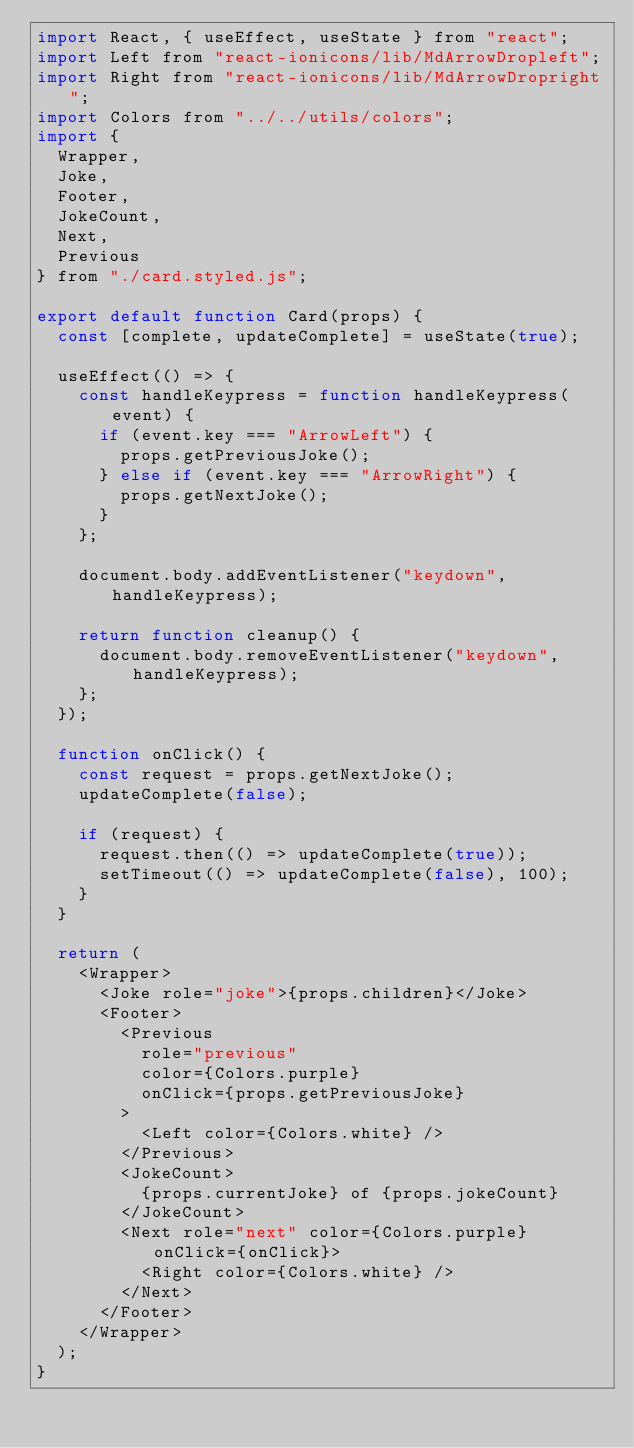Convert code to text. <code><loc_0><loc_0><loc_500><loc_500><_JavaScript_>import React, { useEffect, useState } from "react";
import Left from "react-ionicons/lib/MdArrowDropleft";
import Right from "react-ionicons/lib/MdArrowDropright";
import Colors from "../../utils/colors";
import {
  Wrapper,
  Joke,
  Footer,
  JokeCount,
  Next,
  Previous
} from "./card.styled.js";

export default function Card(props) {
  const [complete, updateComplete] = useState(true);

  useEffect(() => {
    const handleKeypress = function handleKeypress(event) {
      if (event.key === "ArrowLeft") {
        props.getPreviousJoke();
      } else if (event.key === "ArrowRight") {
        props.getNextJoke();
      }
    };

    document.body.addEventListener("keydown", handleKeypress);

    return function cleanup() {
      document.body.removeEventListener("keydown", handleKeypress);
    };
  });

  function onClick() {
    const request = props.getNextJoke();
    updateComplete(false);

    if (request) {
      request.then(() => updateComplete(true));
      setTimeout(() => updateComplete(false), 100);
    }
  }

  return (
    <Wrapper>
      <Joke role="joke">{props.children}</Joke>
      <Footer>
        <Previous
          role="previous"
          color={Colors.purple}
          onClick={props.getPreviousJoke}
        >
          <Left color={Colors.white} />
        </Previous>
        <JokeCount>
          {props.currentJoke} of {props.jokeCount}
        </JokeCount>
        <Next role="next" color={Colors.purple} onClick={onClick}>
          <Right color={Colors.white} />
        </Next>
      </Footer>
    </Wrapper>
  );
}
</code> 